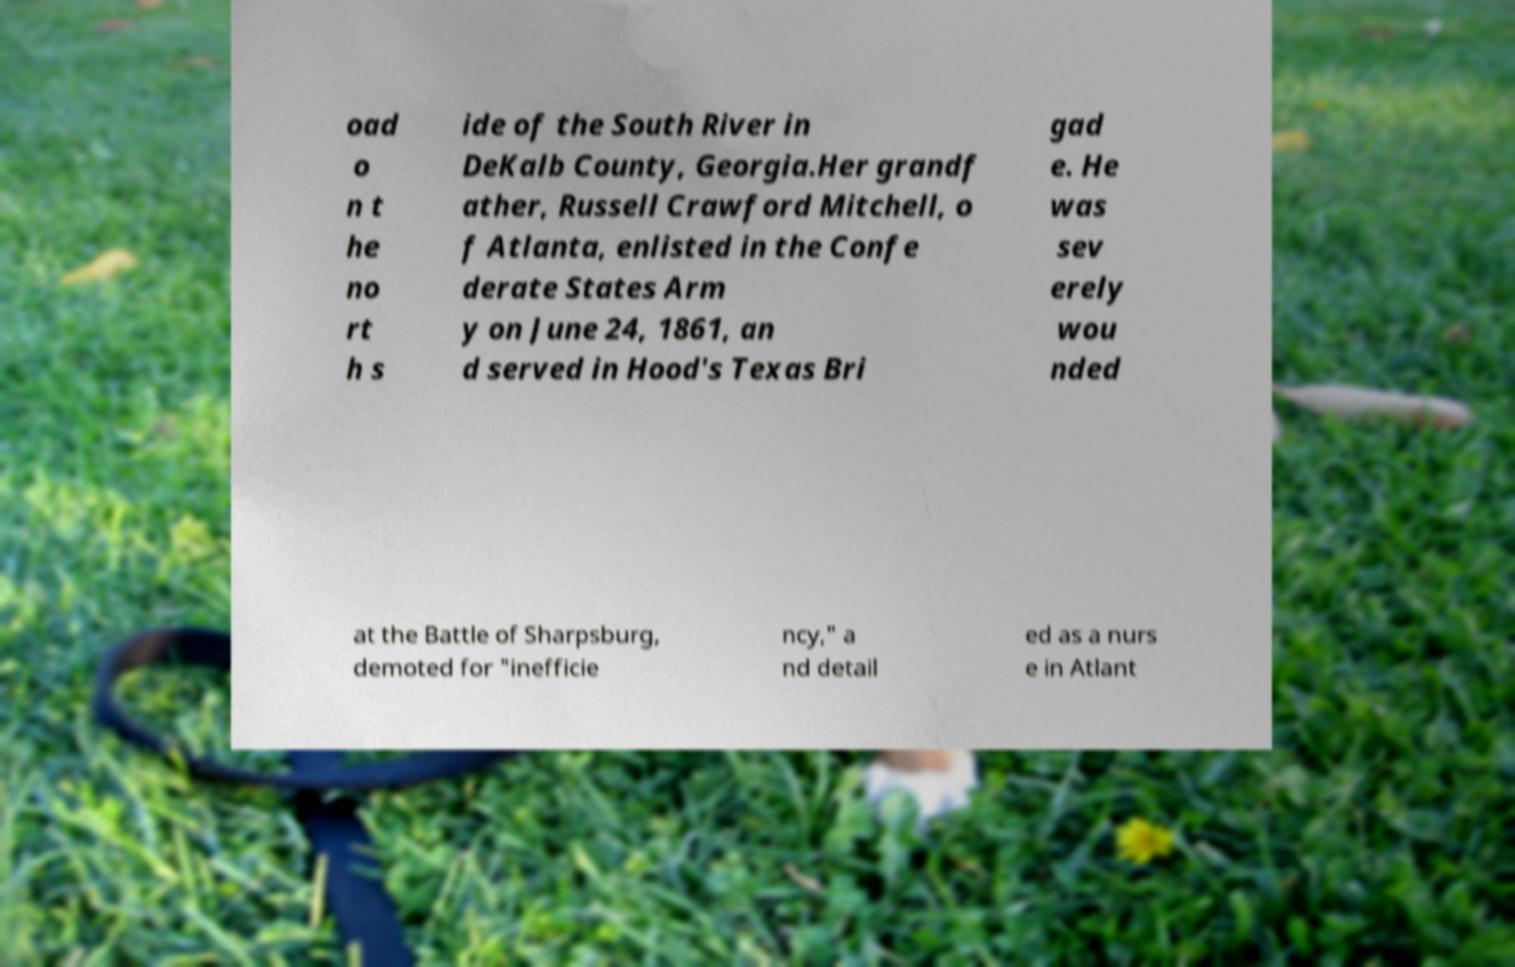Could you extract and type out the text from this image? oad o n t he no rt h s ide of the South River in DeKalb County, Georgia.Her grandf ather, Russell Crawford Mitchell, o f Atlanta, enlisted in the Confe derate States Arm y on June 24, 1861, an d served in Hood's Texas Bri gad e. He was sev erely wou nded at the Battle of Sharpsburg, demoted for "inefficie ncy," a nd detail ed as a nurs e in Atlant 